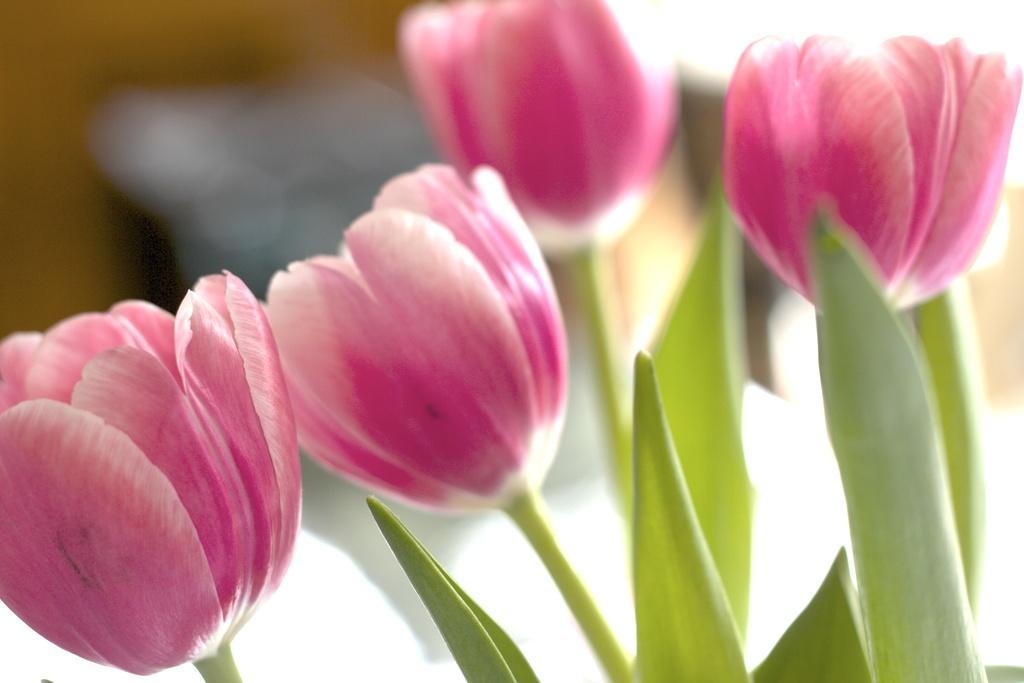In one or two sentences, can you explain what this image depicts? In the image we can see flowers, pink and white in color. These are the leaves and the background is blurred. 